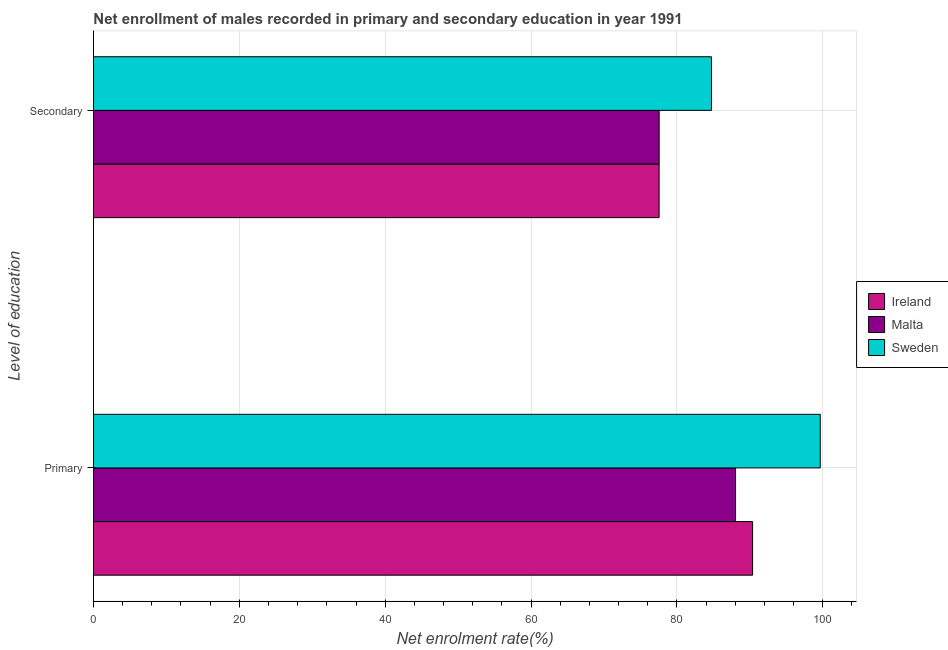How many groups of bars are there?
Keep it short and to the point. 2. Are the number of bars on each tick of the Y-axis equal?
Give a very brief answer. Yes. What is the label of the 1st group of bars from the top?
Provide a succinct answer. Secondary. What is the enrollment rate in primary education in Ireland?
Your answer should be very brief. 90.38. Across all countries, what is the maximum enrollment rate in secondary education?
Your answer should be compact. 84.74. Across all countries, what is the minimum enrollment rate in secondary education?
Provide a short and direct response. 77.57. In which country was the enrollment rate in secondary education minimum?
Your answer should be very brief. Ireland. What is the total enrollment rate in primary education in the graph?
Ensure brevity in your answer.  278.09. What is the difference between the enrollment rate in primary education in Sweden and that in Ireland?
Give a very brief answer. 9.28. What is the difference between the enrollment rate in primary education in Sweden and the enrollment rate in secondary education in Ireland?
Offer a terse response. 22.1. What is the average enrollment rate in primary education per country?
Your answer should be very brief. 92.7. What is the difference between the enrollment rate in secondary education and enrollment rate in primary education in Malta?
Ensure brevity in your answer.  -10.47. In how many countries, is the enrollment rate in primary education greater than 16 %?
Provide a short and direct response. 3. What is the ratio of the enrollment rate in secondary education in Malta to that in Ireland?
Offer a terse response. 1. What does the 1st bar from the top in Secondary represents?
Your response must be concise. Sweden. What does the 1st bar from the bottom in Secondary represents?
Ensure brevity in your answer.  Ireland. How many bars are there?
Offer a terse response. 6. How many countries are there in the graph?
Give a very brief answer. 3. What is the difference between two consecutive major ticks on the X-axis?
Your answer should be compact. 20. Does the graph contain any zero values?
Make the answer very short. No. Where does the legend appear in the graph?
Give a very brief answer. Center right. How many legend labels are there?
Offer a terse response. 3. What is the title of the graph?
Give a very brief answer. Net enrollment of males recorded in primary and secondary education in year 1991. Does "Sierra Leone" appear as one of the legend labels in the graph?
Provide a short and direct response. No. What is the label or title of the X-axis?
Your answer should be compact. Net enrolment rate(%). What is the label or title of the Y-axis?
Make the answer very short. Level of education. What is the Net enrolment rate(%) in Ireland in Primary?
Make the answer very short. 90.38. What is the Net enrolment rate(%) in Malta in Primary?
Provide a succinct answer. 88.05. What is the Net enrolment rate(%) of Sweden in Primary?
Provide a succinct answer. 99.66. What is the Net enrolment rate(%) of Ireland in Secondary?
Your answer should be very brief. 77.57. What is the Net enrolment rate(%) of Malta in Secondary?
Make the answer very short. 77.57. What is the Net enrolment rate(%) in Sweden in Secondary?
Provide a succinct answer. 84.74. Across all Level of education, what is the maximum Net enrolment rate(%) of Ireland?
Make the answer very short. 90.38. Across all Level of education, what is the maximum Net enrolment rate(%) in Malta?
Keep it short and to the point. 88.05. Across all Level of education, what is the maximum Net enrolment rate(%) in Sweden?
Your response must be concise. 99.66. Across all Level of education, what is the minimum Net enrolment rate(%) in Ireland?
Give a very brief answer. 77.57. Across all Level of education, what is the minimum Net enrolment rate(%) in Malta?
Your answer should be compact. 77.57. Across all Level of education, what is the minimum Net enrolment rate(%) in Sweden?
Your answer should be very brief. 84.74. What is the total Net enrolment rate(%) of Ireland in the graph?
Make the answer very short. 167.95. What is the total Net enrolment rate(%) of Malta in the graph?
Offer a very short reply. 165.62. What is the total Net enrolment rate(%) in Sweden in the graph?
Give a very brief answer. 184.41. What is the difference between the Net enrolment rate(%) in Ireland in Primary and that in Secondary?
Your answer should be very brief. 12.82. What is the difference between the Net enrolment rate(%) of Malta in Primary and that in Secondary?
Make the answer very short. 10.47. What is the difference between the Net enrolment rate(%) in Sweden in Primary and that in Secondary?
Ensure brevity in your answer.  14.92. What is the difference between the Net enrolment rate(%) in Ireland in Primary and the Net enrolment rate(%) in Malta in Secondary?
Offer a terse response. 12.81. What is the difference between the Net enrolment rate(%) of Ireland in Primary and the Net enrolment rate(%) of Sweden in Secondary?
Give a very brief answer. 5.64. What is the difference between the Net enrolment rate(%) in Malta in Primary and the Net enrolment rate(%) in Sweden in Secondary?
Your answer should be compact. 3.3. What is the average Net enrolment rate(%) in Ireland per Level of education?
Give a very brief answer. 83.97. What is the average Net enrolment rate(%) in Malta per Level of education?
Provide a succinct answer. 82.81. What is the average Net enrolment rate(%) in Sweden per Level of education?
Ensure brevity in your answer.  92.2. What is the difference between the Net enrolment rate(%) in Ireland and Net enrolment rate(%) in Malta in Primary?
Your response must be concise. 2.34. What is the difference between the Net enrolment rate(%) of Ireland and Net enrolment rate(%) of Sweden in Primary?
Keep it short and to the point. -9.28. What is the difference between the Net enrolment rate(%) in Malta and Net enrolment rate(%) in Sweden in Primary?
Give a very brief answer. -11.62. What is the difference between the Net enrolment rate(%) in Ireland and Net enrolment rate(%) in Malta in Secondary?
Your answer should be compact. -0.01. What is the difference between the Net enrolment rate(%) of Ireland and Net enrolment rate(%) of Sweden in Secondary?
Make the answer very short. -7.18. What is the difference between the Net enrolment rate(%) of Malta and Net enrolment rate(%) of Sweden in Secondary?
Offer a terse response. -7.17. What is the ratio of the Net enrolment rate(%) in Ireland in Primary to that in Secondary?
Ensure brevity in your answer.  1.17. What is the ratio of the Net enrolment rate(%) in Malta in Primary to that in Secondary?
Offer a very short reply. 1.14. What is the ratio of the Net enrolment rate(%) of Sweden in Primary to that in Secondary?
Your answer should be compact. 1.18. What is the difference between the highest and the second highest Net enrolment rate(%) of Ireland?
Your answer should be very brief. 12.82. What is the difference between the highest and the second highest Net enrolment rate(%) in Malta?
Your response must be concise. 10.47. What is the difference between the highest and the second highest Net enrolment rate(%) in Sweden?
Provide a short and direct response. 14.92. What is the difference between the highest and the lowest Net enrolment rate(%) in Ireland?
Provide a succinct answer. 12.82. What is the difference between the highest and the lowest Net enrolment rate(%) in Malta?
Your answer should be very brief. 10.47. What is the difference between the highest and the lowest Net enrolment rate(%) of Sweden?
Your answer should be compact. 14.92. 